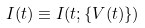Convert formula to latex. <formula><loc_0><loc_0><loc_500><loc_500>I ( t ) \equiv I ( t ; \{ V ( t ) \} )</formula> 